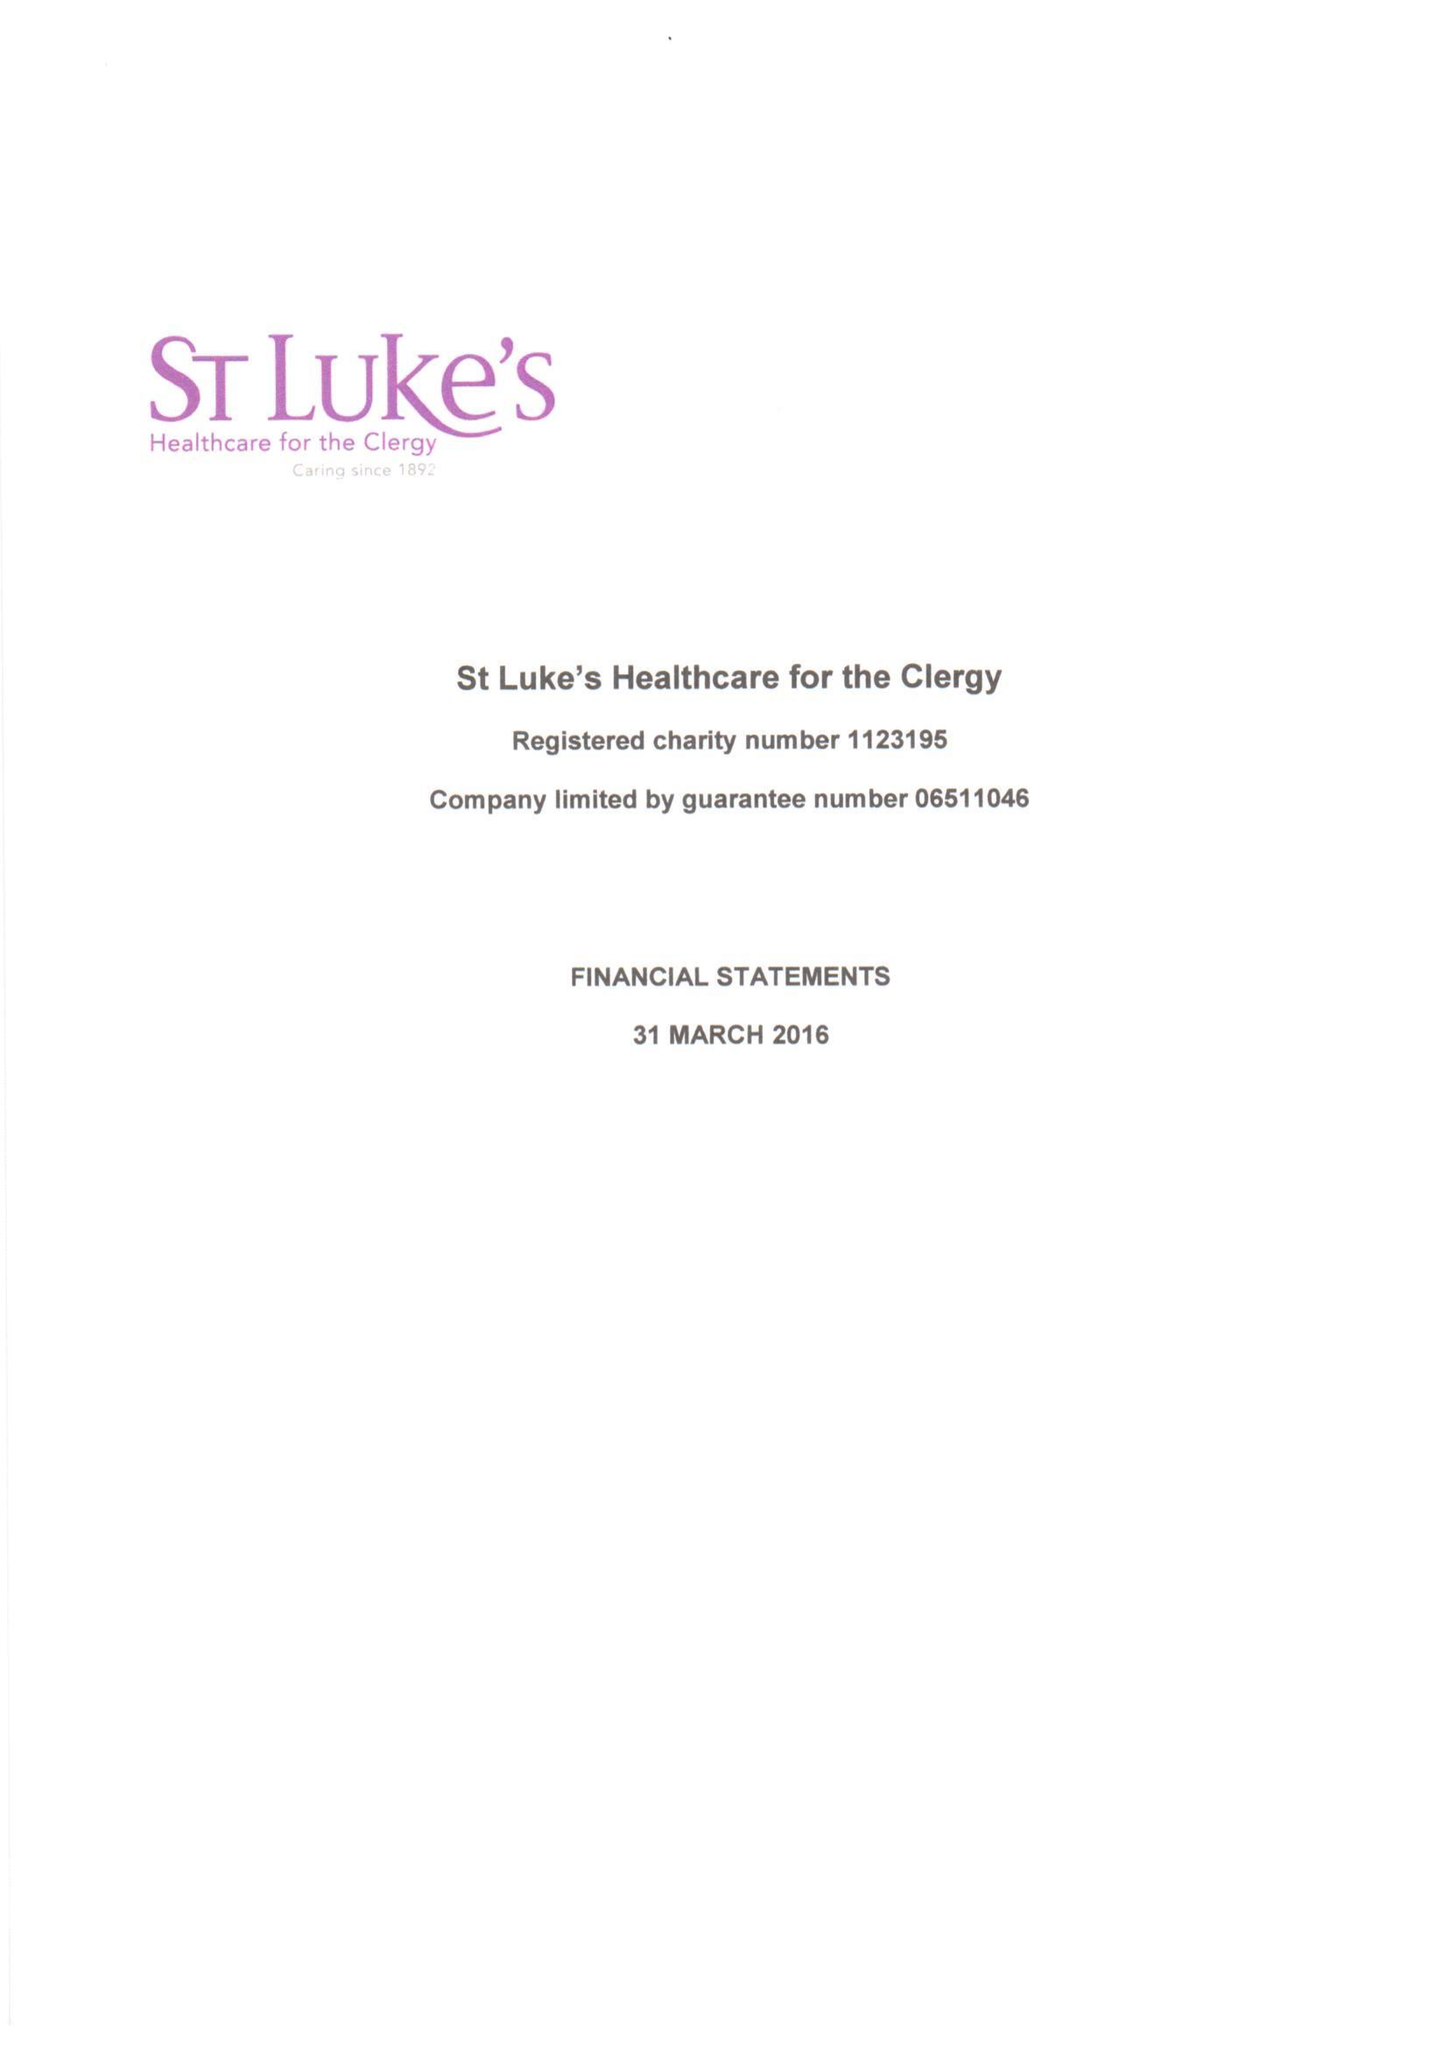What is the value for the income_annually_in_british_pounds?
Answer the question using a single word or phrase. 413032.00 